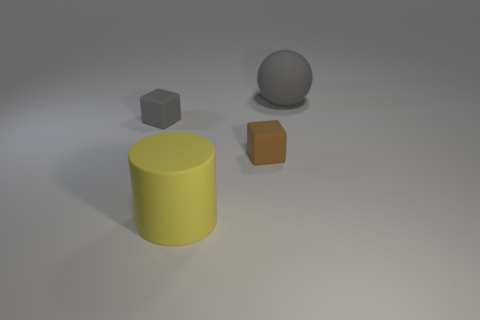Add 1 yellow objects. How many objects exist? 5 Subtract all spheres. How many objects are left? 3 Subtract all tiny matte objects. Subtract all large purple objects. How many objects are left? 2 Add 1 small brown matte objects. How many small brown matte objects are left? 2 Add 4 brown cylinders. How many brown cylinders exist? 4 Subtract 0 yellow spheres. How many objects are left? 4 